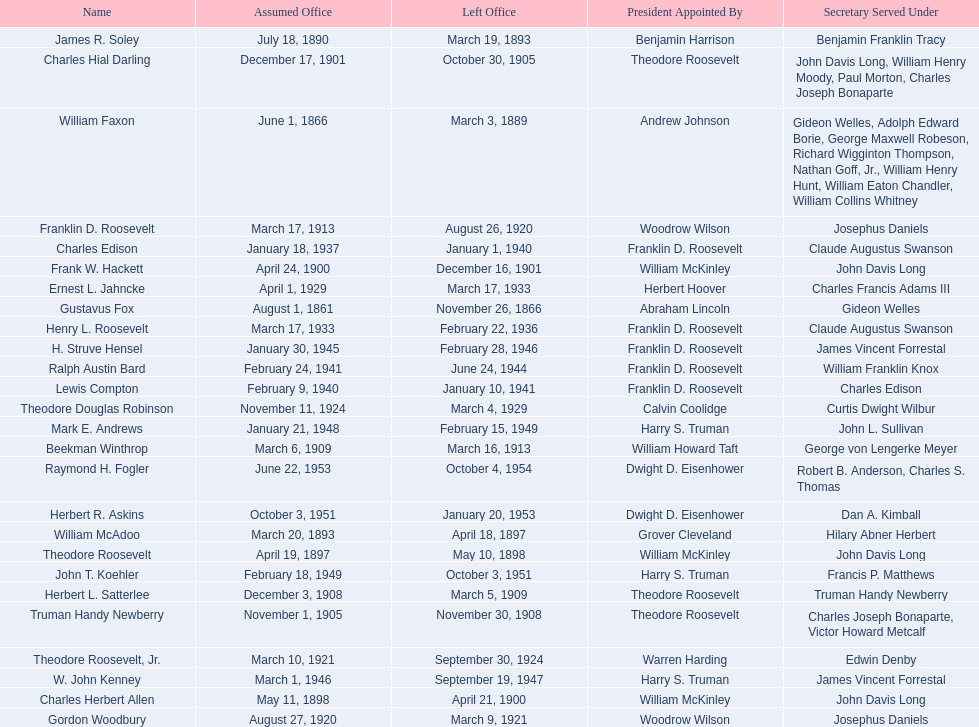Parse the table in full. {'header': ['Name', 'Assumed Office', 'Left Office', 'President Appointed By', 'Secretary Served Under'], 'rows': [['James R. Soley', 'July 18, 1890', 'March 19, 1893', 'Benjamin Harrison', 'Benjamin Franklin Tracy'], ['Charles Hial Darling', 'December 17, 1901', 'October 30, 1905', 'Theodore Roosevelt', 'John Davis Long, William Henry Moody, Paul Morton, Charles Joseph Bonaparte'], ['William Faxon', 'June 1, 1866', 'March 3, 1889', 'Andrew Johnson', 'Gideon Welles, Adolph Edward Borie, George Maxwell Robeson, Richard Wigginton Thompson, Nathan Goff, Jr., William Henry Hunt, William Eaton Chandler, William Collins Whitney'], ['Franklin D. Roosevelt', 'March 17, 1913', 'August 26, 1920', 'Woodrow Wilson', 'Josephus Daniels'], ['Charles Edison', 'January 18, 1937', 'January 1, 1940', 'Franklin D. Roosevelt', 'Claude Augustus Swanson'], ['Frank W. Hackett', 'April 24, 1900', 'December 16, 1901', 'William McKinley', 'John Davis Long'], ['Ernest L. Jahncke', 'April 1, 1929', 'March 17, 1933', 'Herbert Hoover', 'Charles Francis Adams III'], ['Gustavus Fox', 'August 1, 1861', 'November 26, 1866', 'Abraham Lincoln', 'Gideon Welles'], ['Henry L. Roosevelt', 'March 17, 1933', 'February 22, 1936', 'Franklin D. Roosevelt', 'Claude Augustus Swanson'], ['H. Struve Hensel', 'January 30, 1945', 'February 28, 1946', 'Franklin D. Roosevelt', 'James Vincent Forrestal'], ['Ralph Austin Bard', 'February 24, 1941', 'June 24, 1944', 'Franklin D. Roosevelt', 'William Franklin Knox'], ['Lewis Compton', 'February 9, 1940', 'January 10, 1941', 'Franklin D. Roosevelt', 'Charles Edison'], ['Theodore Douglas Robinson', 'November 11, 1924', 'March 4, 1929', 'Calvin Coolidge', 'Curtis Dwight Wilbur'], ['Mark E. Andrews', 'January 21, 1948', 'February 15, 1949', 'Harry S. Truman', 'John L. Sullivan'], ['Beekman Winthrop', 'March 6, 1909', 'March 16, 1913', 'William Howard Taft', 'George von Lengerke Meyer'], ['Raymond H. Fogler', 'June 22, 1953', 'October 4, 1954', 'Dwight D. Eisenhower', 'Robert B. Anderson, Charles S. Thomas'], ['Herbert R. Askins', 'October 3, 1951', 'January 20, 1953', 'Dwight D. Eisenhower', 'Dan A. Kimball'], ['William McAdoo', 'March 20, 1893', 'April 18, 1897', 'Grover Cleveland', 'Hilary Abner Herbert'], ['Theodore Roosevelt', 'April 19, 1897', 'May 10, 1898', 'William McKinley', 'John Davis Long'], ['John T. Koehler', 'February 18, 1949', 'October 3, 1951', 'Harry S. Truman', 'Francis P. Matthews'], ['Herbert L. Satterlee', 'December 3, 1908', 'March 5, 1909', 'Theodore Roosevelt', 'Truman Handy Newberry'], ['Truman Handy Newberry', 'November 1, 1905', 'November 30, 1908', 'Theodore Roosevelt', 'Charles Joseph Bonaparte, Victor Howard Metcalf'], ['Theodore Roosevelt, Jr.', 'March 10, 1921', 'September 30, 1924', 'Warren Harding', 'Edwin Denby'], ['W. John Kenney', 'March 1, 1946', 'September 19, 1947', 'Harry S. Truman', 'James Vincent Forrestal'], ['Charles Herbert Allen', 'May 11, 1898', 'April 21, 1900', 'William McKinley', 'John Davis Long'], ['Gordon Woodbury', 'August 27, 1920', 'March 9, 1921', 'Woodrow Wilson', 'Josephus Daniels']]} What are all the names? Gustavus Fox, William Faxon, James R. Soley, William McAdoo, Theodore Roosevelt, Charles Herbert Allen, Frank W. Hackett, Charles Hial Darling, Truman Handy Newberry, Herbert L. Satterlee, Beekman Winthrop, Franklin D. Roosevelt, Gordon Woodbury, Theodore Roosevelt, Jr., Theodore Douglas Robinson, Ernest L. Jahncke, Henry L. Roosevelt, Charles Edison, Lewis Compton, Ralph Austin Bard, H. Struve Hensel, W. John Kenney, Mark E. Andrews, John T. Koehler, Herbert R. Askins, Raymond H. Fogler. When did they leave office? November 26, 1866, March 3, 1889, March 19, 1893, April 18, 1897, May 10, 1898, April 21, 1900, December 16, 1901, October 30, 1905, November 30, 1908, March 5, 1909, March 16, 1913, August 26, 1920, March 9, 1921, September 30, 1924, March 4, 1929, March 17, 1933, February 22, 1936, January 1, 1940, January 10, 1941, June 24, 1944, February 28, 1946, September 19, 1947, February 15, 1949, October 3, 1951, January 20, 1953, October 4, 1954. And when did raymond h. fogler leave? October 4, 1954. 